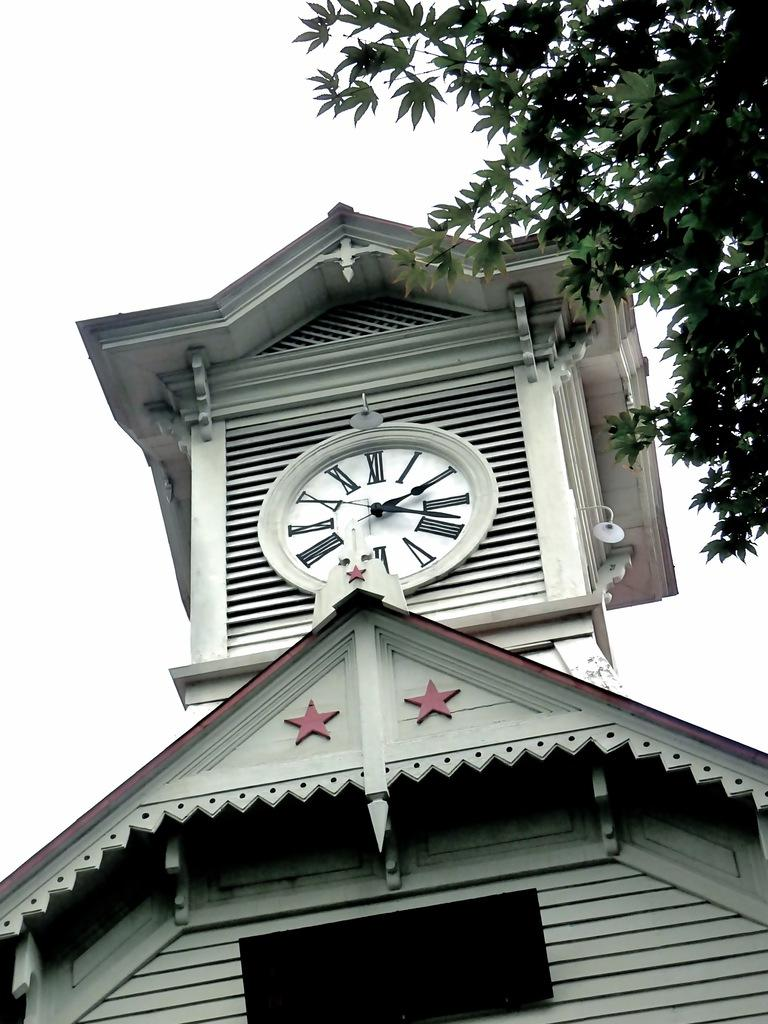<image>
Relay a brief, clear account of the picture shown. The top of an old clock tower reading two twenty 